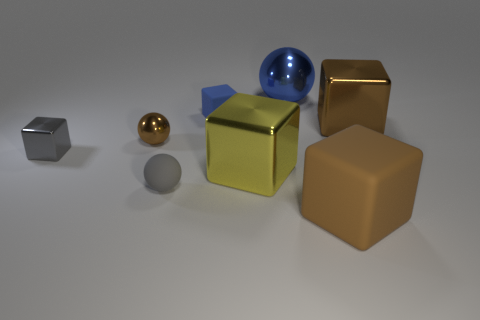How many brown cubes must be subtracted to get 1 brown cubes? 1 Subtract all spheres. How many objects are left? 5 Subtract 5 cubes. How many cubes are left? 0 Subtract all yellow cubes. Subtract all purple cylinders. How many cubes are left? 4 Subtract all brown balls. How many yellow cubes are left? 1 Subtract all gray metallic things. Subtract all gray balls. How many objects are left? 6 Add 8 large matte blocks. How many large matte blocks are left? 9 Add 6 small gray objects. How many small gray objects exist? 8 Add 1 tiny cubes. How many objects exist? 9 Subtract all blue cubes. How many cubes are left? 4 